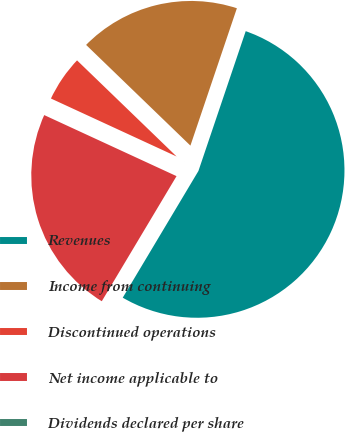<chart> <loc_0><loc_0><loc_500><loc_500><pie_chart><fcel>Revenues<fcel>Income from continuing<fcel>Discontinued operations<fcel>Net income applicable to<fcel>Dividends declared per share<nl><fcel>53.38%<fcel>17.97%<fcel>5.34%<fcel>23.31%<fcel>0.0%<nl></chart> 